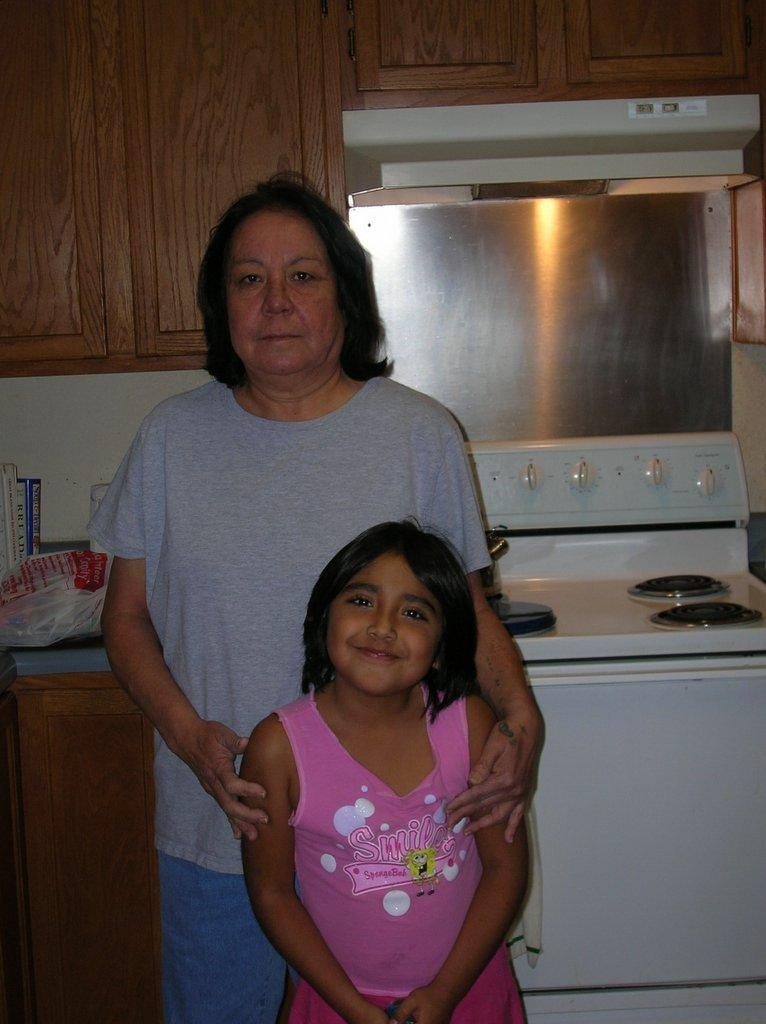<image>
Write a terse but informative summary of the picture. A shirt with sponge bob on the front wants you to smile. 